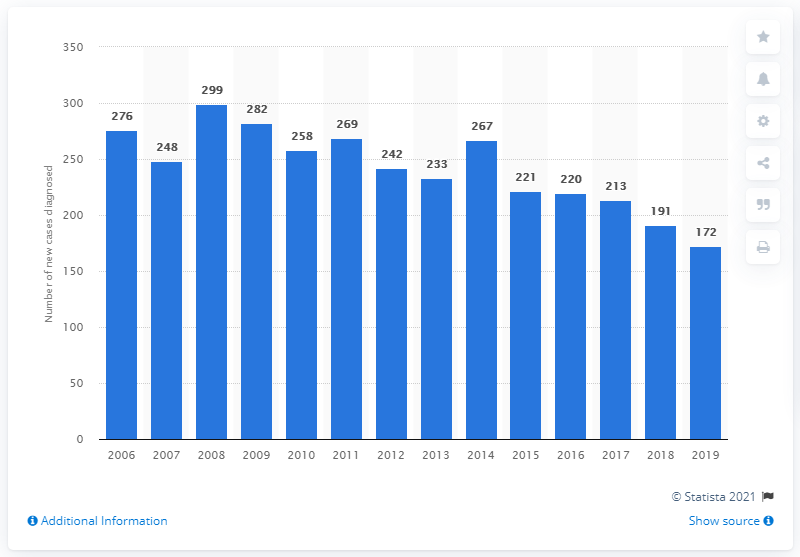List a handful of essential elements in this visual. In 2019, there were 172 new cases of HIV in Norway. 